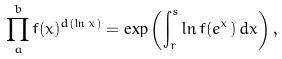<formula> <loc_0><loc_0><loc_500><loc_500>\prod _ { a } ^ { b } f ( x ) ^ { d ( \ln x ) } = \exp \left ( \int _ { r } ^ { s } \ln f ( e ^ { x } ) \, d x \right ) ,</formula> 